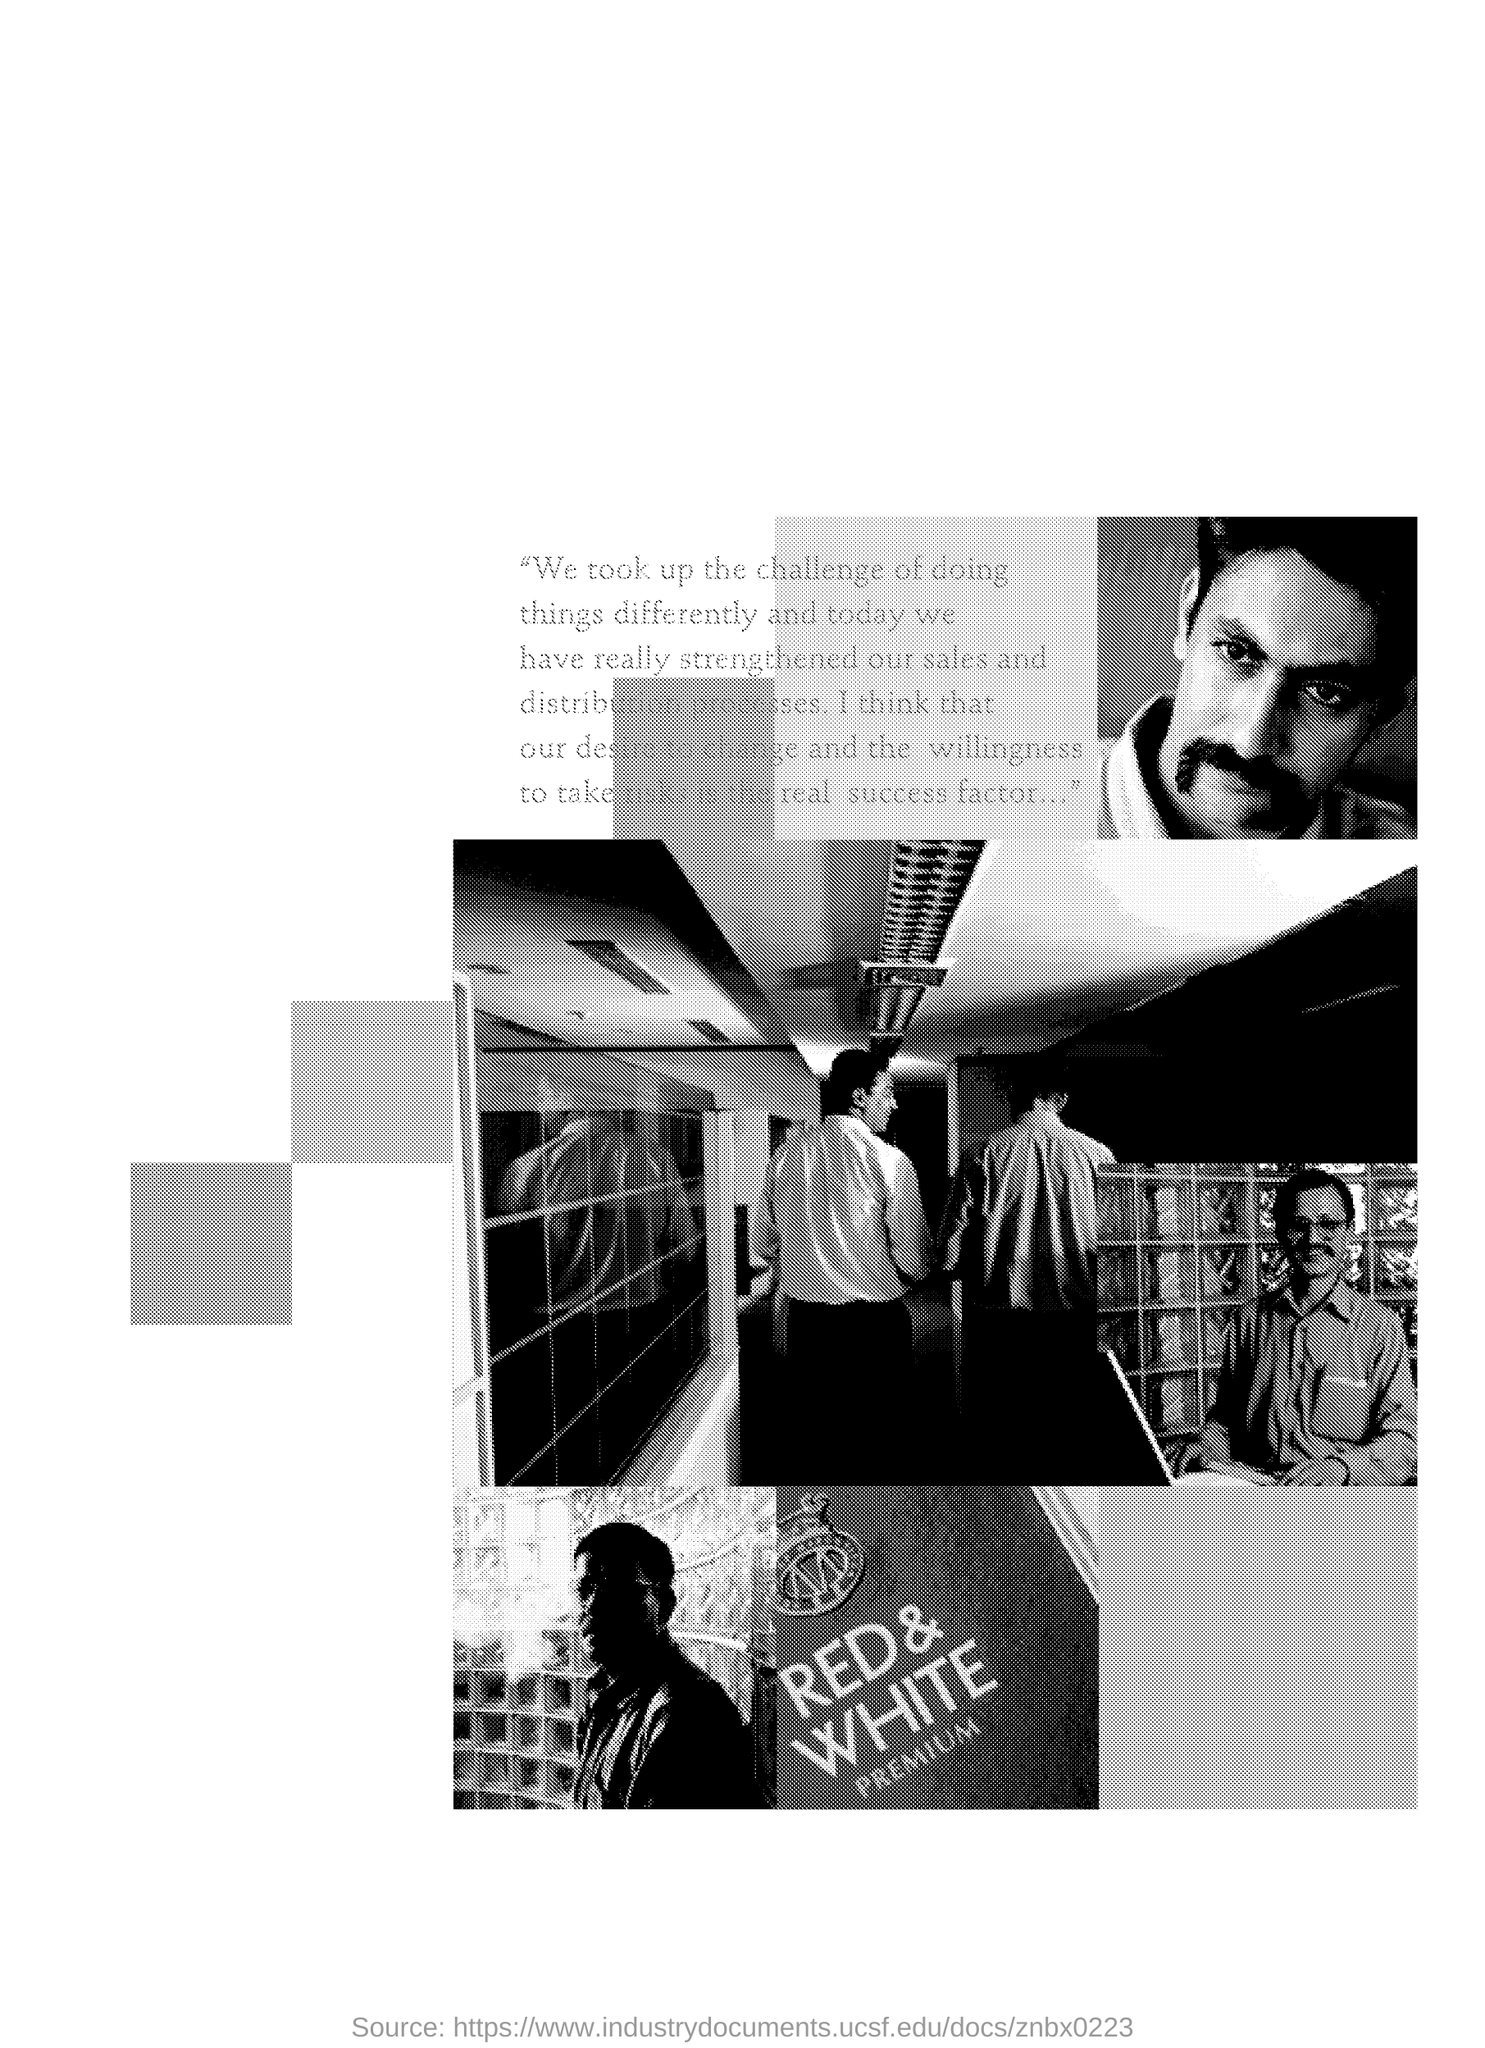Outline some significant characteristics in this image. The document mentions the brand Red & White premium. 